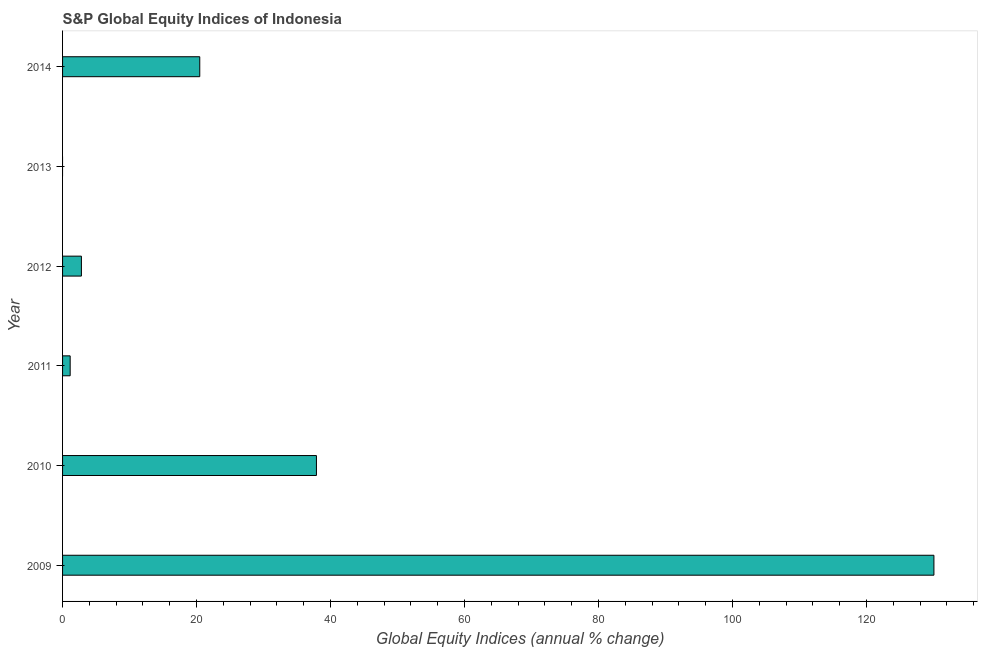Does the graph contain any zero values?
Your answer should be compact. Yes. Does the graph contain grids?
Offer a terse response. No. What is the title of the graph?
Provide a succinct answer. S&P Global Equity Indices of Indonesia. What is the label or title of the X-axis?
Ensure brevity in your answer.  Global Equity Indices (annual % change). What is the label or title of the Y-axis?
Ensure brevity in your answer.  Year. What is the s&p global equity indices in 2012?
Give a very brief answer. 2.81. Across all years, what is the maximum s&p global equity indices?
Your response must be concise. 130.07. What is the sum of the s&p global equity indices?
Offer a very short reply. 192.39. What is the difference between the s&p global equity indices in 2009 and 2014?
Your answer should be very brief. 109.59. What is the average s&p global equity indices per year?
Offer a very short reply. 32.06. What is the median s&p global equity indices?
Offer a terse response. 11.65. What is the ratio of the s&p global equity indices in 2011 to that in 2014?
Your response must be concise. 0.06. Is the difference between the s&p global equity indices in 2009 and 2014 greater than the difference between any two years?
Offer a very short reply. No. What is the difference between the highest and the second highest s&p global equity indices?
Your response must be concise. 92.17. Is the sum of the s&p global equity indices in 2010 and 2014 greater than the maximum s&p global equity indices across all years?
Your answer should be compact. No. What is the difference between the highest and the lowest s&p global equity indices?
Provide a short and direct response. 130.07. How many bars are there?
Your answer should be compact. 5. How many years are there in the graph?
Your answer should be compact. 6. What is the Global Equity Indices (annual % change) of 2009?
Ensure brevity in your answer.  130.07. What is the Global Equity Indices (annual % change) of 2010?
Your answer should be compact. 37.89. What is the Global Equity Indices (annual % change) in 2011?
Your response must be concise. 1.14. What is the Global Equity Indices (annual % change) in 2012?
Your answer should be compact. 2.81. What is the Global Equity Indices (annual % change) of 2013?
Your answer should be compact. 0. What is the Global Equity Indices (annual % change) of 2014?
Give a very brief answer. 20.48. What is the difference between the Global Equity Indices (annual % change) in 2009 and 2010?
Ensure brevity in your answer.  92.17. What is the difference between the Global Equity Indices (annual % change) in 2009 and 2011?
Keep it short and to the point. 128.93. What is the difference between the Global Equity Indices (annual % change) in 2009 and 2012?
Your answer should be compact. 127.26. What is the difference between the Global Equity Indices (annual % change) in 2009 and 2014?
Provide a succinct answer. 109.59. What is the difference between the Global Equity Indices (annual % change) in 2010 and 2011?
Provide a short and direct response. 36.76. What is the difference between the Global Equity Indices (annual % change) in 2010 and 2012?
Keep it short and to the point. 35.08. What is the difference between the Global Equity Indices (annual % change) in 2010 and 2014?
Ensure brevity in your answer.  17.41. What is the difference between the Global Equity Indices (annual % change) in 2011 and 2012?
Provide a short and direct response. -1.68. What is the difference between the Global Equity Indices (annual % change) in 2011 and 2014?
Your answer should be compact. -19.34. What is the difference between the Global Equity Indices (annual % change) in 2012 and 2014?
Provide a succinct answer. -17.67. What is the ratio of the Global Equity Indices (annual % change) in 2009 to that in 2010?
Provide a short and direct response. 3.43. What is the ratio of the Global Equity Indices (annual % change) in 2009 to that in 2011?
Make the answer very short. 114.51. What is the ratio of the Global Equity Indices (annual % change) in 2009 to that in 2012?
Your response must be concise. 46.27. What is the ratio of the Global Equity Indices (annual % change) in 2009 to that in 2014?
Provide a short and direct response. 6.35. What is the ratio of the Global Equity Indices (annual % change) in 2010 to that in 2011?
Ensure brevity in your answer.  33.36. What is the ratio of the Global Equity Indices (annual % change) in 2010 to that in 2012?
Keep it short and to the point. 13.48. What is the ratio of the Global Equity Indices (annual % change) in 2010 to that in 2014?
Provide a succinct answer. 1.85. What is the ratio of the Global Equity Indices (annual % change) in 2011 to that in 2012?
Your response must be concise. 0.4. What is the ratio of the Global Equity Indices (annual % change) in 2011 to that in 2014?
Ensure brevity in your answer.  0.06. What is the ratio of the Global Equity Indices (annual % change) in 2012 to that in 2014?
Provide a succinct answer. 0.14. 